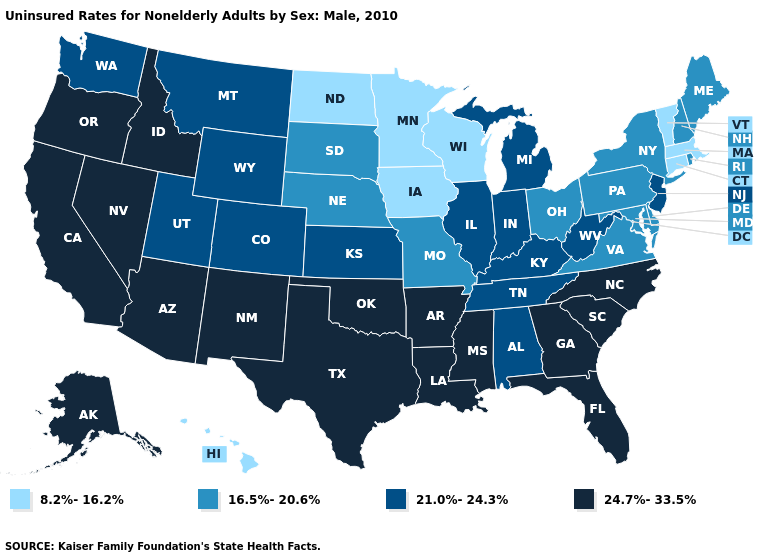Does Hawaii have the lowest value in the USA?
Keep it brief. Yes. Which states have the lowest value in the West?
Concise answer only. Hawaii. What is the lowest value in the USA?
Answer briefly. 8.2%-16.2%. Name the states that have a value in the range 21.0%-24.3%?
Keep it brief. Alabama, Colorado, Illinois, Indiana, Kansas, Kentucky, Michigan, Montana, New Jersey, Tennessee, Utah, Washington, West Virginia, Wyoming. Does Iowa have the lowest value in the USA?
Keep it brief. Yes. What is the value of South Carolina?
Be succinct. 24.7%-33.5%. Does Alabama have the lowest value in the South?
Short answer required. No. Does Georgia have the highest value in the South?
Be succinct. Yes. Does Iowa have the same value as Wisconsin?
Keep it brief. Yes. Among the states that border Illinois , which have the lowest value?
Be succinct. Iowa, Wisconsin. Does New Mexico have a higher value than New Jersey?
Write a very short answer. Yes. What is the highest value in the West ?
Short answer required. 24.7%-33.5%. Does Nebraska have a higher value than Minnesota?
Quick response, please. Yes. Does Colorado have the lowest value in the USA?
Write a very short answer. No. 